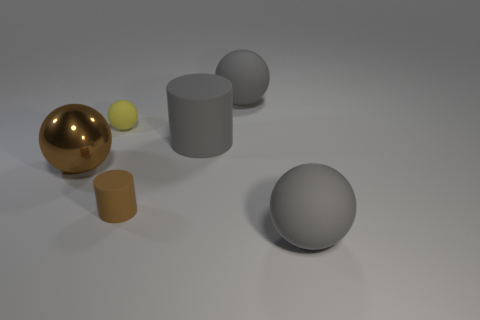Do the tiny matte cylinder and the big metal ball have the same color?
Keep it short and to the point. Yes. There is another thing that is the same color as the shiny thing; what material is it?
Your response must be concise. Rubber. There is a matte thing that is the same color as the large metallic thing; what is its size?
Provide a short and direct response. Small. Are there any other things that have the same material as the brown sphere?
Offer a very short reply. No. Is there a big sphere?
Your answer should be compact. Yes. Does the large shiny ball have the same color as the matte cylinder that is in front of the brown sphere?
Keep it short and to the point. Yes. What size is the brown object to the right of the big thing on the left side of the rubber thing left of the tiny brown rubber cylinder?
Ensure brevity in your answer.  Small. What number of tiny rubber objects are the same color as the large cylinder?
Your answer should be compact. 0. How many things are either blue metallic things or gray balls in front of the small ball?
Make the answer very short. 1. The tiny rubber sphere is what color?
Your response must be concise. Yellow. 